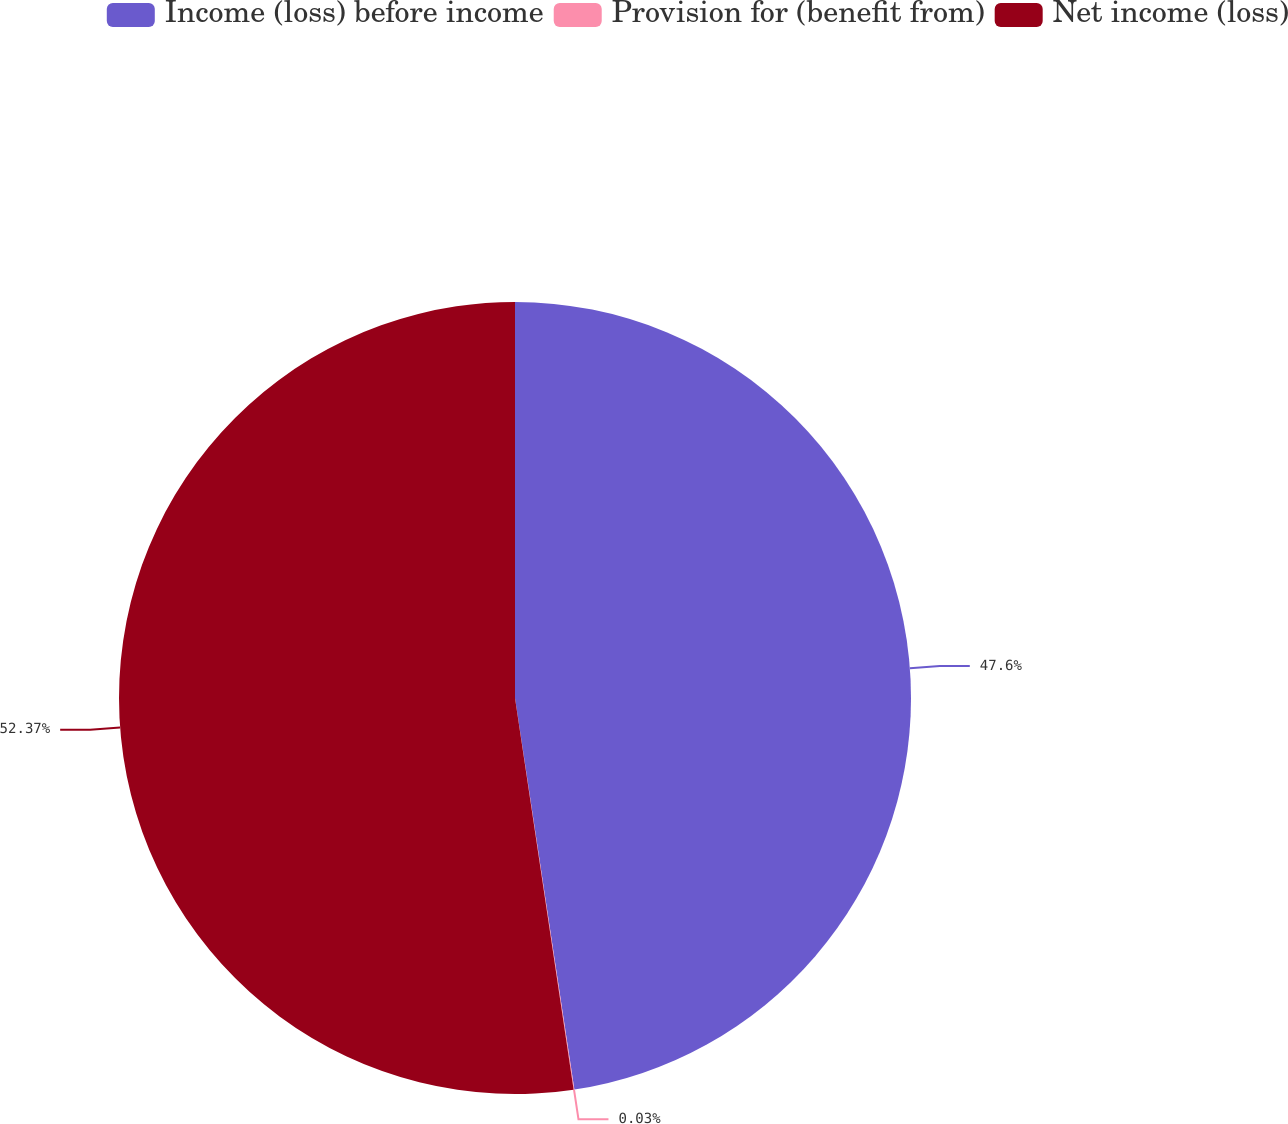Convert chart. <chart><loc_0><loc_0><loc_500><loc_500><pie_chart><fcel>Income (loss) before income<fcel>Provision for (benefit from)<fcel>Net income (loss)<nl><fcel>47.6%<fcel>0.03%<fcel>52.36%<nl></chart> 